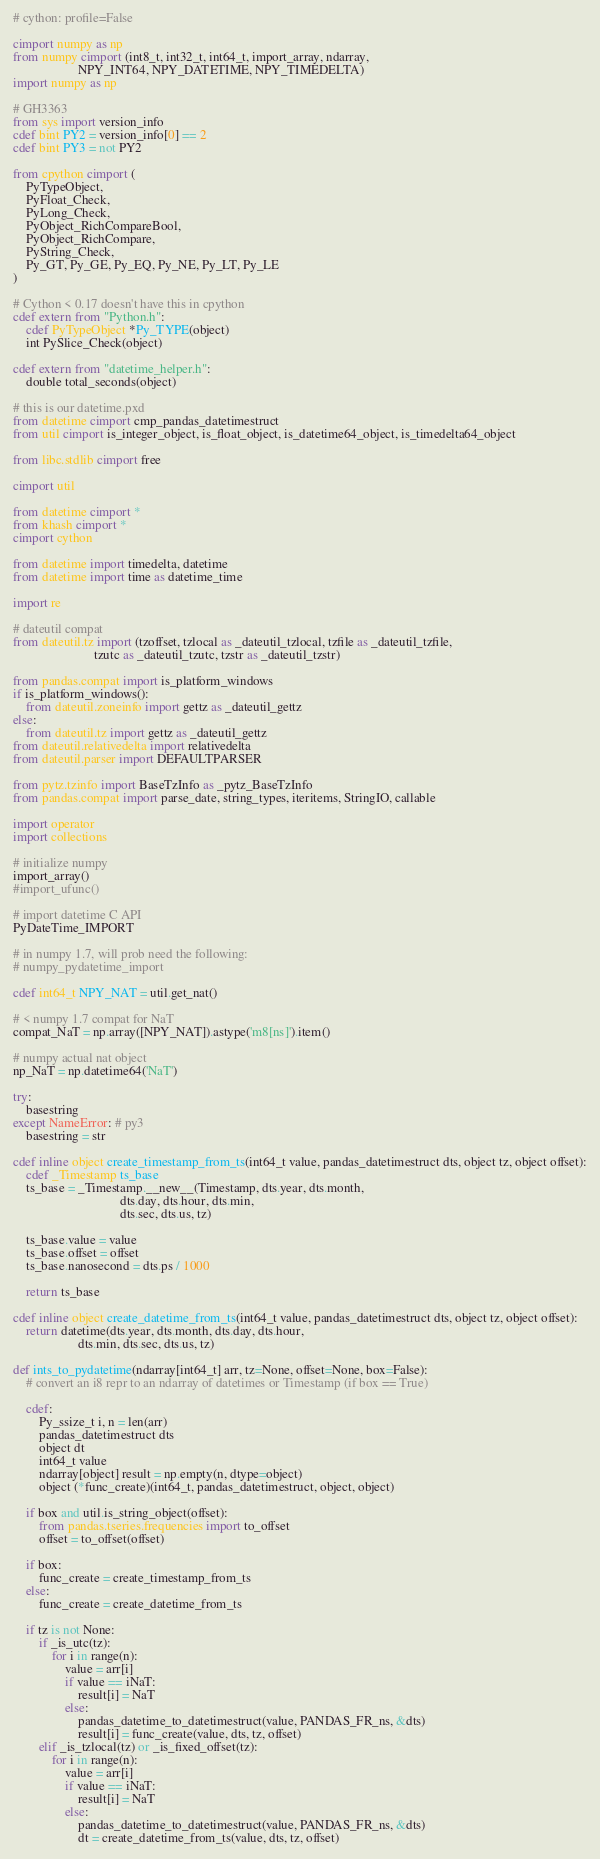Convert code to text. <code><loc_0><loc_0><loc_500><loc_500><_Cython_># cython: profile=False

cimport numpy as np
from numpy cimport (int8_t, int32_t, int64_t, import_array, ndarray,
                    NPY_INT64, NPY_DATETIME, NPY_TIMEDELTA)
import numpy as np

# GH3363
from sys import version_info
cdef bint PY2 = version_info[0] == 2
cdef bint PY3 = not PY2

from cpython cimport (
    PyTypeObject,
    PyFloat_Check,
    PyLong_Check,
    PyObject_RichCompareBool,
    PyObject_RichCompare,
    PyString_Check,
    Py_GT, Py_GE, Py_EQ, Py_NE, Py_LT, Py_LE
)

# Cython < 0.17 doesn't have this in cpython
cdef extern from "Python.h":
    cdef PyTypeObject *Py_TYPE(object)
    int PySlice_Check(object)

cdef extern from "datetime_helper.h":
    double total_seconds(object)

# this is our datetime.pxd
from datetime cimport cmp_pandas_datetimestruct
from util cimport is_integer_object, is_float_object, is_datetime64_object, is_timedelta64_object

from libc.stdlib cimport free

cimport util

from datetime cimport *
from khash cimport *
cimport cython

from datetime import timedelta, datetime
from datetime import time as datetime_time

import re

# dateutil compat
from dateutil.tz import (tzoffset, tzlocal as _dateutil_tzlocal, tzfile as _dateutil_tzfile,
                         tzutc as _dateutil_tzutc, tzstr as _dateutil_tzstr)

from pandas.compat import is_platform_windows
if is_platform_windows():
    from dateutil.zoneinfo import gettz as _dateutil_gettz
else:
    from dateutil.tz import gettz as _dateutil_gettz
from dateutil.relativedelta import relativedelta
from dateutil.parser import DEFAULTPARSER

from pytz.tzinfo import BaseTzInfo as _pytz_BaseTzInfo
from pandas.compat import parse_date, string_types, iteritems, StringIO, callable

import operator
import collections

# initialize numpy
import_array()
#import_ufunc()

# import datetime C API
PyDateTime_IMPORT

# in numpy 1.7, will prob need the following:
# numpy_pydatetime_import

cdef int64_t NPY_NAT = util.get_nat()

# < numpy 1.7 compat for NaT
compat_NaT = np.array([NPY_NAT]).astype('m8[ns]').item()

# numpy actual nat object
np_NaT = np.datetime64('NaT')

try:
    basestring
except NameError: # py3
    basestring = str

cdef inline object create_timestamp_from_ts(int64_t value, pandas_datetimestruct dts, object tz, object offset):
    cdef _Timestamp ts_base
    ts_base = _Timestamp.__new__(Timestamp, dts.year, dts.month,
                                 dts.day, dts.hour, dts.min,
                                 dts.sec, dts.us, tz)

    ts_base.value = value
    ts_base.offset = offset
    ts_base.nanosecond = dts.ps / 1000

    return ts_base

cdef inline object create_datetime_from_ts(int64_t value, pandas_datetimestruct dts, object tz, object offset):
    return datetime(dts.year, dts.month, dts.day, dts.hour,
                    dts.min, dts.sec, dts.us, tz)

def ints_to_pydatetime(ndarray[int64_t] arr, tz=None, offset=None, box=False):
    # convert an i8 repr to an ndarray of datetimes or Timestamp (if box == True)

    cdef:
        Py_ssize_t i, n = len(arr)
        pandas_datetimestruct dts
        object dt
        int64_t value
        ndarray[object] result = np.empty(n, dtype=object)
        object (*func_create)(int64_t, pandas_datetimestruct, object, object)

    if box and util.is_string_object(offset):
        from pandas.tseries.frequencies import to_offset
        offset = to_offset(offset)

    if box:
        func_create = create_timestamp_from_ts
    else:
        func_create = create_datetime_from_ts

    if tz is not None:
        if _is_utc(tz):
            for i in range(n):
                value = arr[i]
                if value == iNaT:
                    result[i] = NaT
                else:
                    pandas_datetime_to_datetimestruct(value, PANDAS_FR_ns, &dts)
                    result[i] = func_create(value, dts, tz, offset)
        elif _is_tzlocal(tz) or _is_fixed_offset(tz):
            for i in range(n):
                value = arr[i]
                if value == iNaT:
                    result[i] = NaT
                else:
                    pandas_datetime_to_datetimestruct(value, PANDAS_FR_ns, &dts)
                    dt = create_datetime_from_ts(value, dts, tz, offset)</code> 